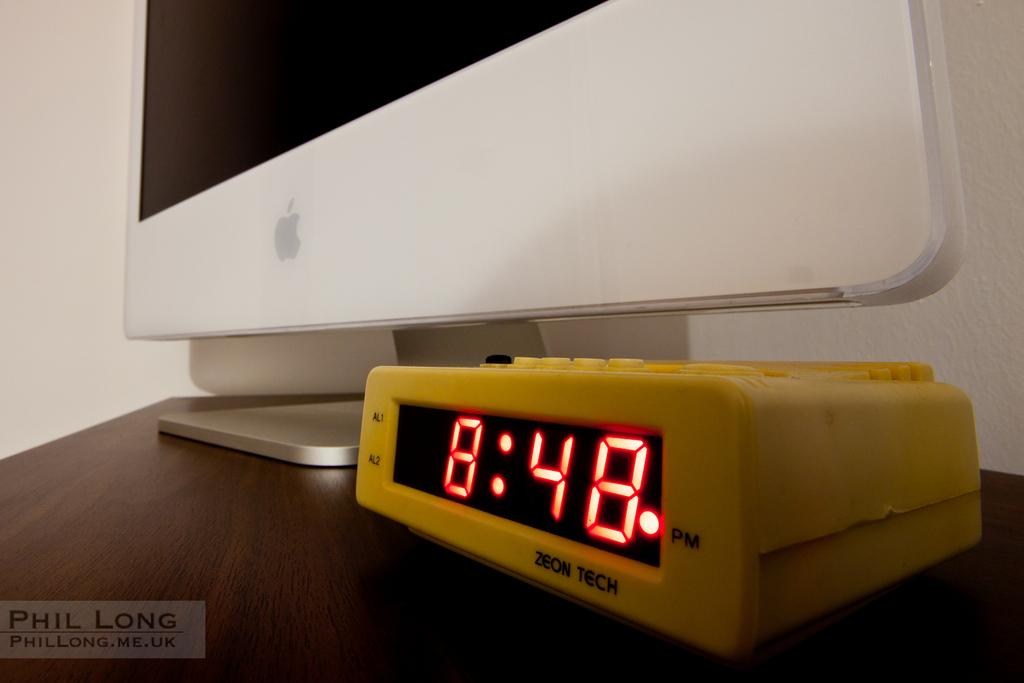<image>
Write a terse but informative summary of the picture. The clock next to the monitor states that it is 8:48 pm. 